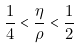<formula> <loc_0><loc_0><loc_500><loc_500>\frac { 1 } { 4 } < \frac { \eta } { \rho } < \frac { 1 } { 2 }</formula> 